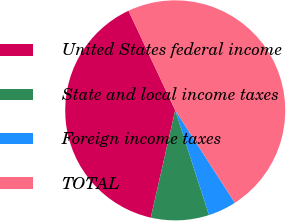<chart> <loc_0><loc_0><loc_500><loc_500><pie_chart><fcel>United States federal income<fcel>State and local income taxes<fcel>Foreign income taxes<fcel>TOTAL<nl><fcel>39.45%<fcel>8.53%<fcel>4.16%<fcel>47.86%<nl></chart> 